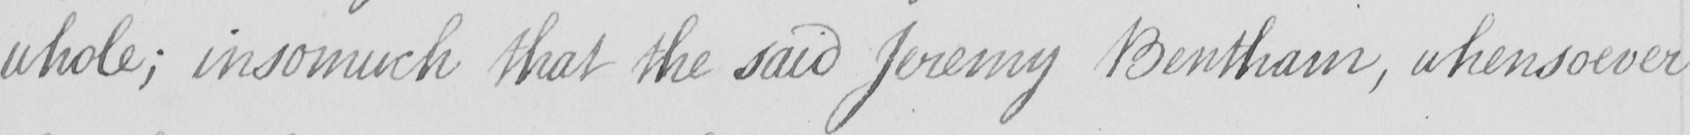What is written in this line of handwriting? whole ; insomuch that the said Jeremy Bentham , whensoever 